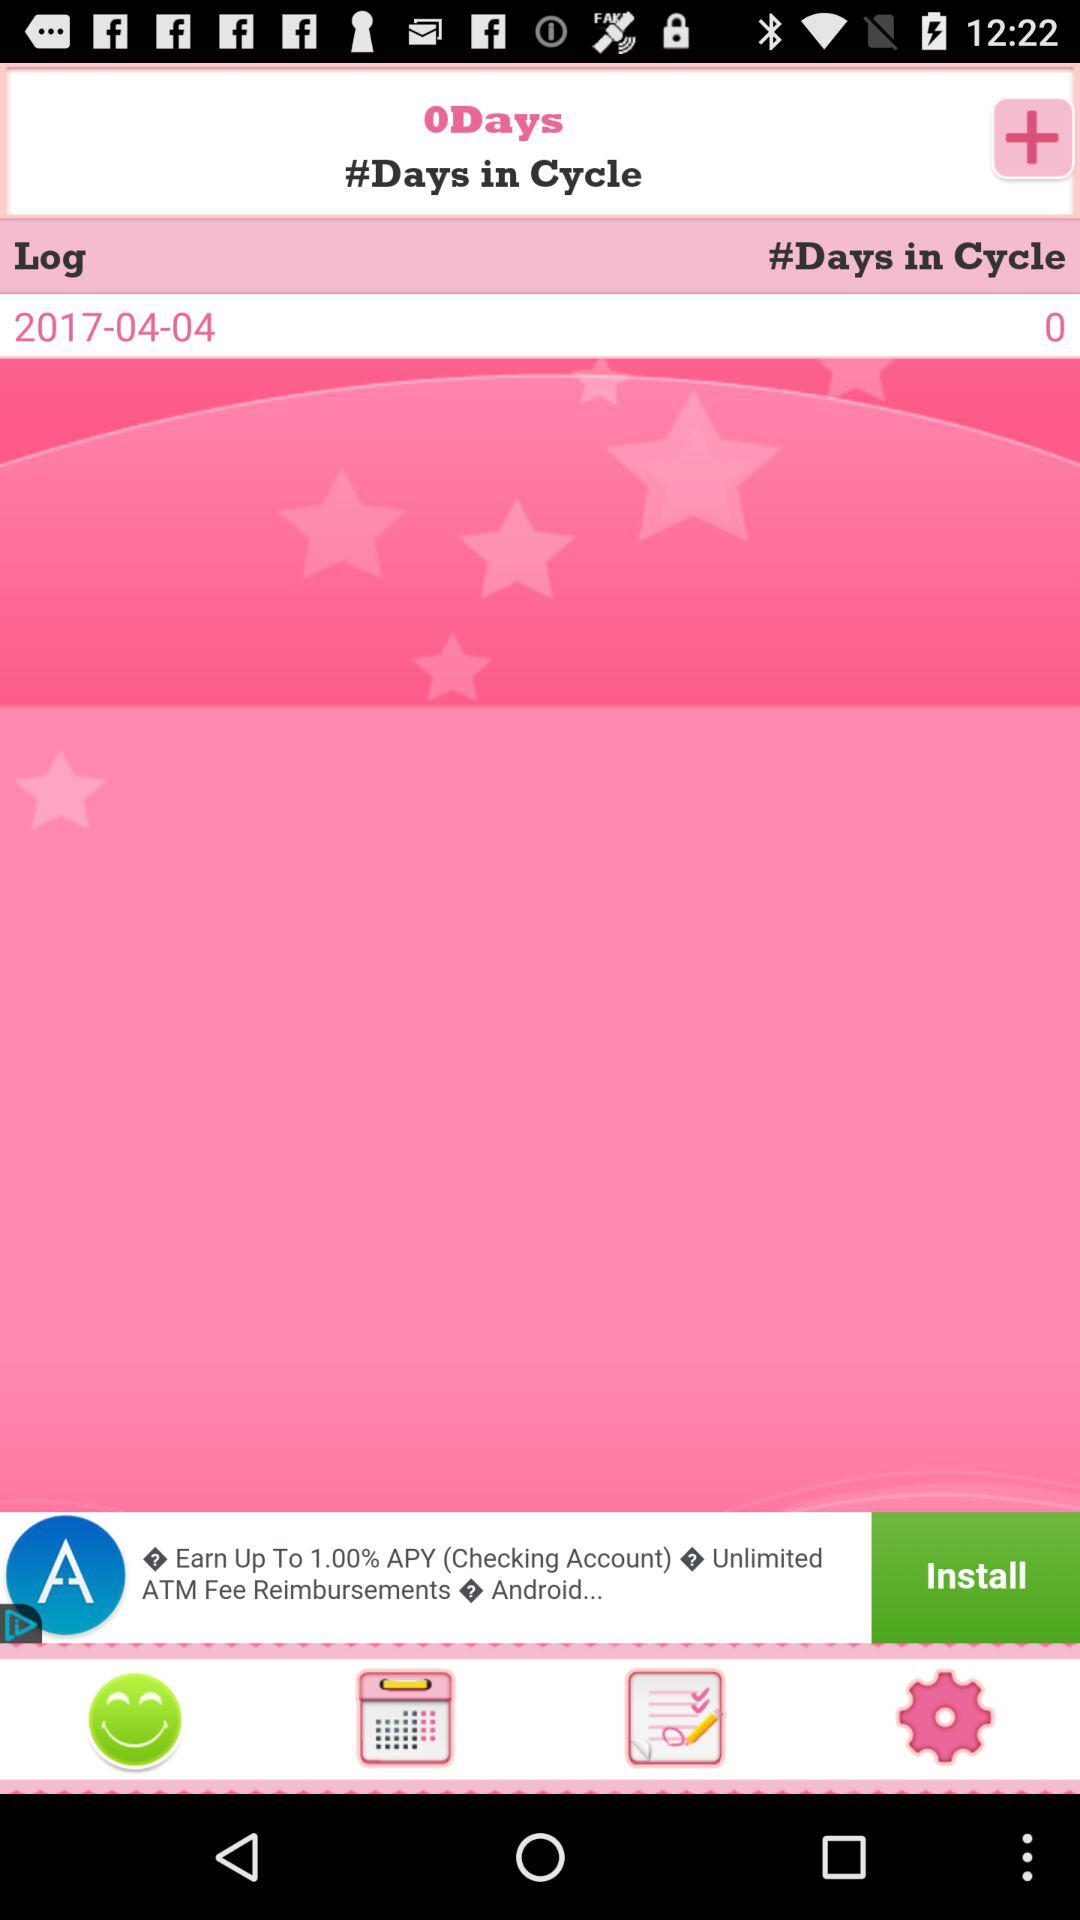How many days are in a cycle? There is 1 day in a cycle. 